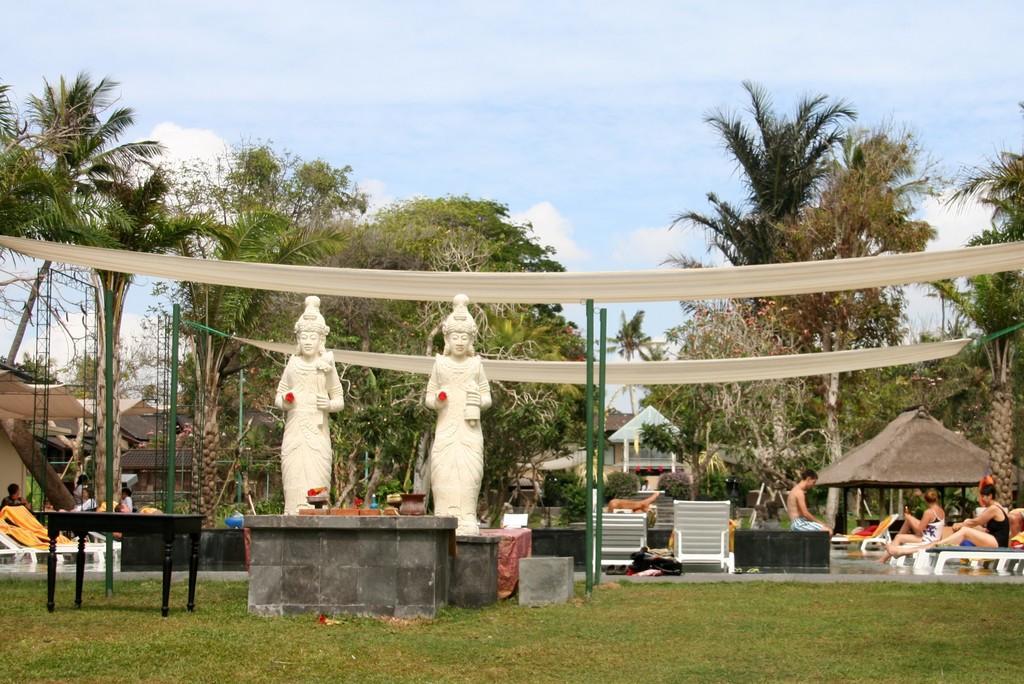In one or two sentences, can you explain what this image depicts? In this image in the front there's grass on the ground. In the center there are statue, there are tables, chairs and there are persons sitting. In the background there are trees, tents and the sky is cloudy. 